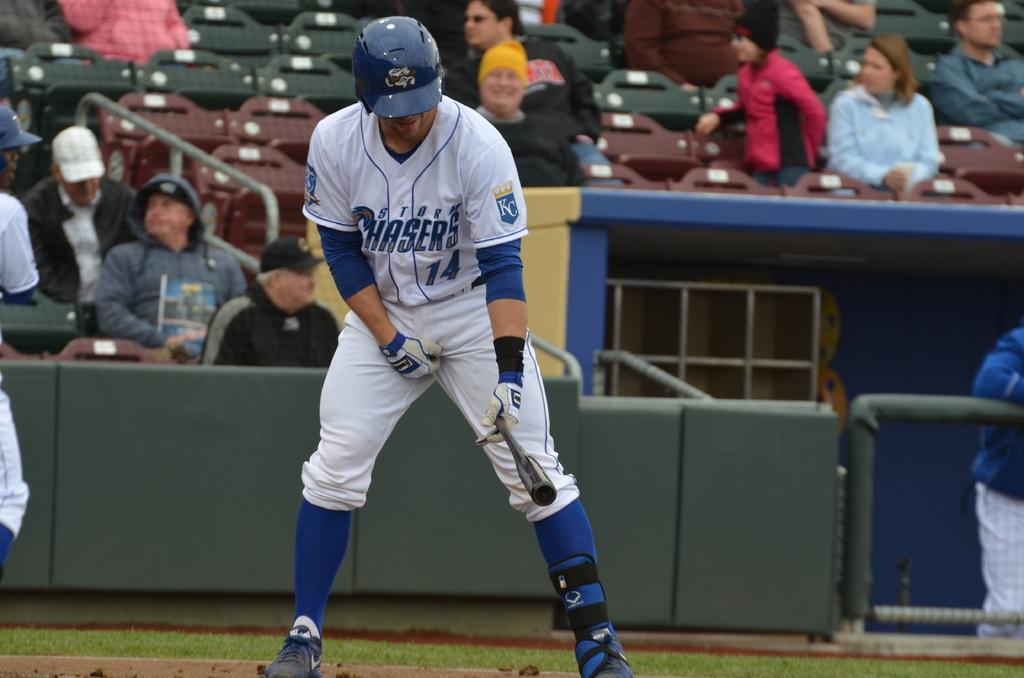Can you describe this image briefly? In the picture I can see a person wearing white color dress, helmet, gloves, socks and shoes is holding a baseball bat in his hands and standing on the ground. The background of the image is blurred, where we can see a few people are sitting on the chairs inside a stadium. 